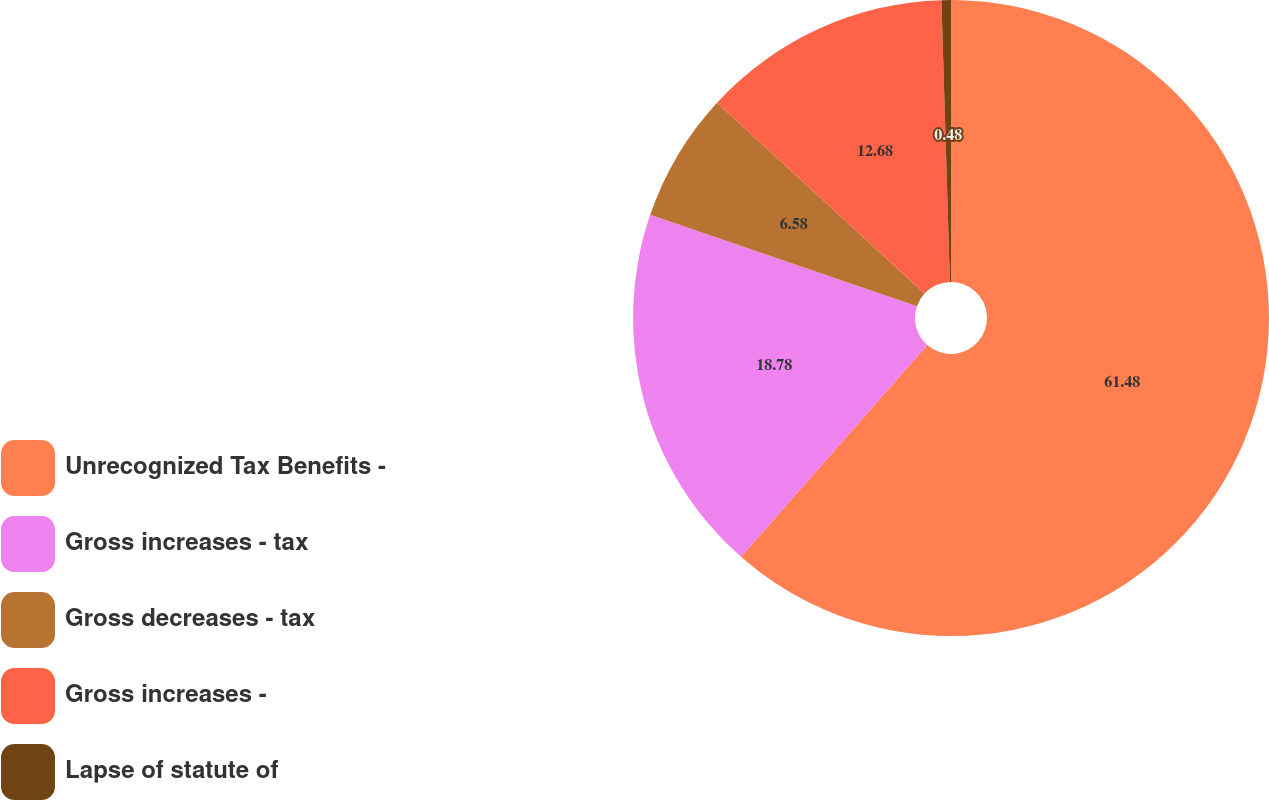<chart> <loc_0><loc_0><loc_500><loc_500><pie_chart><fcel>Unrecognized Tax Benefits -<fcel>Gross increases - tax<fcel>Gross decreases - tax<fcel>Gross increases -<fcel>Lapse of statute of<nl><fcel>61.47%<fcel>18.78%<fcel>6.58%<fcel>12.68%<fcel>0.48%<nl></chart> 